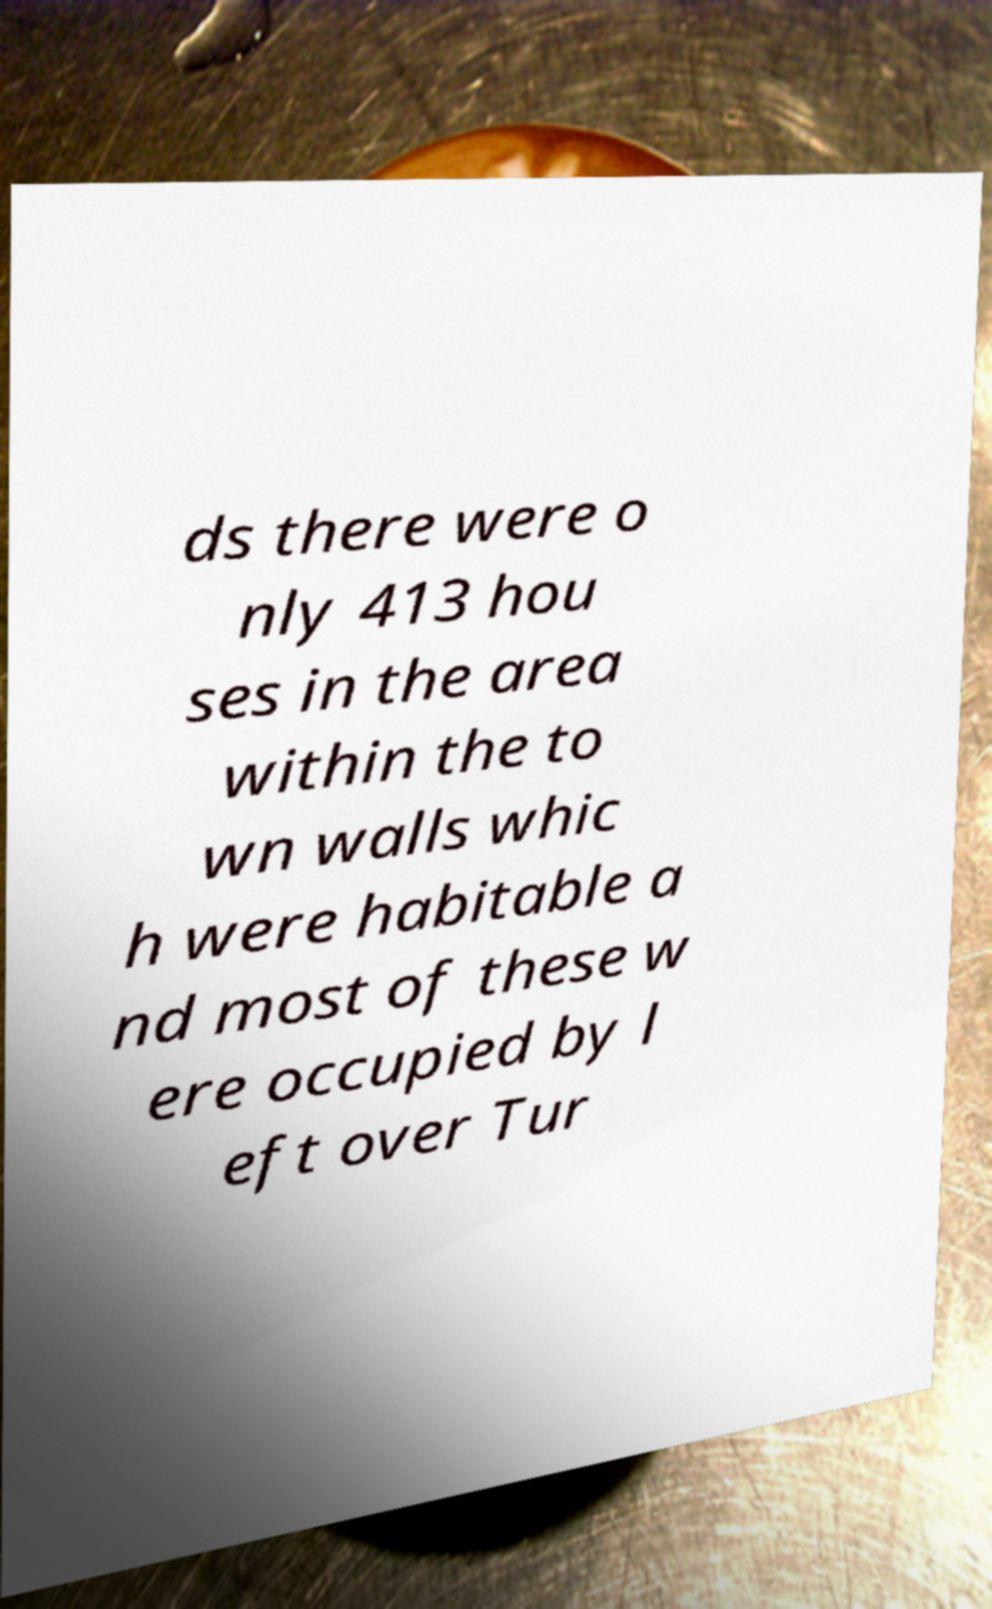Can you read and provide the text displayed in the image?This photo seems to have some interesting text. Can you extract and type it out for me? ds there were o nly 413 hou ses in the area within the to wn walls whic h were habitable a nd most of these w ere occupied by l eft over Tur 